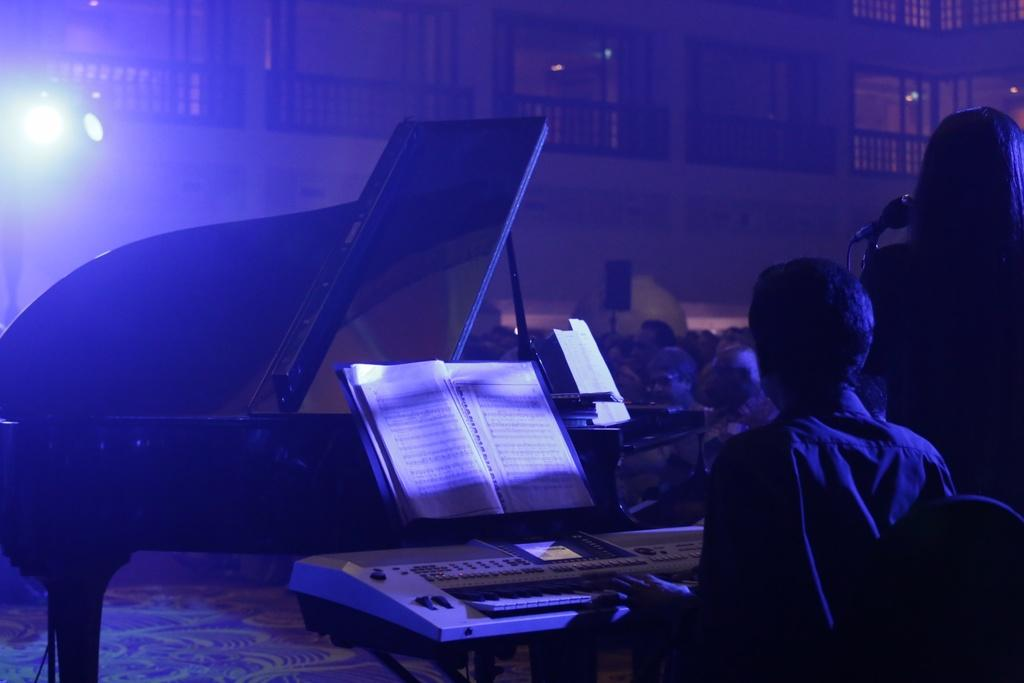What is the woman doing in the image? The woman is standing in front of a mic. What is the man doing in the image? The man is playing a piano keyboard. What object is placed in front of the piano keyboard? There is a book in front of the piano keyboard. Who else is present in the image besides the woman and the man? There are audience members present in the image. Can you see the ocean in the background of the image? No, the ocean is not present in the image. 